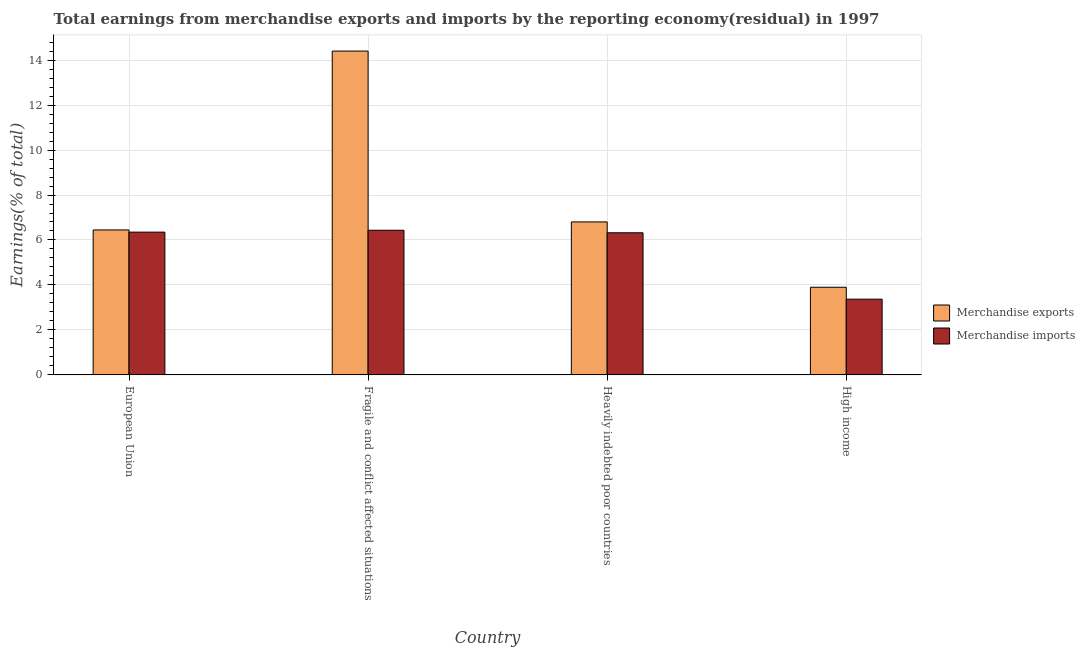How many different coloured bars are there?
Make the answer very short. 2. How many groups of bars are there?
Your response must be concise. 4. Are the number of bars per tick equal to the number of legend labels?
Your answer should be very brief. Yes. Are the number of bars on each tick of the X-axis equal?
Provide a succinct answer. Yes. What is the label of the 1st group of bars from the left?
Your answer should be compact. European Union. In how many cases, is the number of bars for a given country not equal to the number of legend labels?
Offer a terse response. 0. What is the earnings from merchandise imports in European Union?
Your response must be concise. 6.35. Across all countries, what is the maximum earnings from merchandise imports?
Your answer should be compact. 6.43. Across all countries, what is the minimum earnings from merchandise exports?
Ensure brevity in your answer.  3.9. In which country was the earnings from merchandise exports maximum?
Ensure brevity in your answer.  Fragile and conflict affected situations. What is the total earnings from merchandise imports in the graph?
Ensure brevity in your answer.  22.47. What is the difference between the earnings from merchandise imports in Fragile and conflict affected situations and that in Heavily indebted poor countries?
Your answer should be compact. 0.11. What is the difference between the earnings from merchandise exports in Heavily indebted poor countries and the earnings from merchandise imports in Fragile and conflict affected situations?
Ensure brevity in your answer.  0.37. What is the average earnings from merchandise imports per country?
Make the answer very short. 5.62. What is the difference between the earnings from merchandise imports and earnings from merchandise exports in European Union?
Give a very brief answer. -0.1. What is the ratio of the earnings from merchandise exports in Heavily indebted poor countries to that in High income?
Provide a short and direct response. 1.75. What is the difference between the highest and the second highest earnings from merchandise exports?
Offer a very short reply. 7.6. What is the difference between the highest and the lowest earnings from merchandise imports?
Make the answer very short. 3.06. In how many countries, is the earnings from merchandise exports greater than the average earnings from merchandise exports taken over all countries?
Keep it short and to the point. 1. What does the 2nd bar from the left in Heavily indebted poor countries represents?
Your answer should be compact. Merchandise imports. How many bars are there?
Offer a very short reply. 8. How many countries are there in the graph?
Make the answer very short. 4. Does the graph contain grids?
Offer a very short reply. Yes. Where does the legend appear in the graph?
Make the answer very short. Center right. How many legend labels are there?
Offer a very short reply. 2. What is the title of the graph?
Ensure brevity in your answer.  Total earnings from merchandise exports and imports by the reporting economy(residual) in 1997. What is the label or title of the X-axis?
Make the answer very short. Country. What is the label or title of the Y-axis?
Provide a short and direct response. Earnings(% of total). What is the Earnings(% of total) in Merchandise exports in European Union?
Provide a short and direct response. 6.45. What is the Earnings(% of total) of Merchandise imports in European Union?
Keep it short and to the point. 6.35. What is the Earnings(% of total) in Merchandise exports in Fragile and conflict affected situations?
Make the answer very short. 14.4. What is the Earnings(% of total) of Merchandise imports in Fragile and conflict affected situations?
Your response must be concise. 6.43. What is the Earnings(% of total) of Merchandise exports in Heavily indebted poor countries?
Your answer should be very brief. 6.8. What is the Earnings(% of total) in Merchandise imports in Heavily indebted poor countries?
Keep it short and to the point. 6.32. What is the Earnings(% of total) of Merchandise exports in High income?
Provide a succinct answer. 3.9. What is the Earnings(% of total) of Merchandise imports in High income?
Provide a short and direct response. 3.37. Across all countries, what is the maximum Earnings(% of total) in Merchandise exports?
Your answer should be compact. 14.4. Across all countries, what is the maximum Earnings(% of total) of Merchandise imports?
Make the answer very short. 6.43. Across all countries, what is the minimum Earnings(% of total) of Merchandise exports?
Keep it short and to the point. 3.9. Across all countries, what is the minimum Earnings(% of total) of Merchandise imports?
Give a very brief answer. 3.37. What is the total Earnings(% of total) of Merchandise exports in the graph?
Give a very brief answer. 31.55. What is the total Earnings(% of total) in Merchandise imports in the graph?
Provide a succinct answer. 22.47. What is the difference between the Earnings(% of total) of Merchandise exports in European Union and that in Fragile and conflict affected situations?
Provide a succinct answer. -7.95. What is the difference between the Earnings(% of total) in Merchandise imports in European Union and that in Fragile and conflict affected situations?
Make the answer very short. -0.08. What is the difference between the Earnings(% of total) in Merchandise exports in European Union and that in Heavily indebted poor countries?
Your answer should be very brief. -0.36. What is the difference between the Earnings(% of total) of Merchandise imports in European Union and that in Heavily indebted poor countries?
Offer a very short reply. 0.03. What is the difference between the Earnings(% of total) in Merchandise exports in European Union and that in High income?
Make the answer very short. 2.55. What is the difference between the Earnings(% of total) in Merchandise imports in European Union and that in High income?
Offer a terse response. 2.98. What is the difference between the Earnings(% of total) of Merchandise exports in Fragile and conflict affected situations and that in Heavily indebted poor countries?
Give a very brief answer. 7.6. What is the difference between the Earnings(% of total) in Merchandise imports in Fragile and conflict affected situations and that in Heavily indebted poor countries?
Ensure brevity in your answer.  0.11. What is the difference between the Earnings(% of total) of Merchandise exports in Fragile and conflict affected situations and that in High income?
Offer a very short reply. 10.5. What is the difference between the Earnings(% of total) of Merchandise imports in Fragile and conflict affected situations and that in High income?
Your answer should be compact. 3.06. What is the difference between the Earnings(% of total) in Merchandise exports in Heavily indebted poor countries and that in High income?
Ensure brevity in your answer.  2.91. What is the difference between the Earnings(% of total) in Merchandise imports in Heavily indebted poor countries and that in High income?
Make the answer very short. 2.95. What is the difference between the Earnings(% of total) in Merchandise exports in European Union and the Earnings(% of total) in Merchandise imports in Fragile and conflict affected situations?
Your answer should be very brief. 0.01. What is the difference between the Earnings(% of total) of Merchandise exports in European Union and the Earnings(% of total) of Merchandise imports in Heavily indebted poor countries?
Ensure brevity in your answer.  0.13. What is the difference between the Earnings(% of total) of Merchandise exports in European Union and the Earnings(% of total) of Merchandise imports in High income?
Your answer should be compact. 3.08. What is the difference between the Earnings(% of total) in Merchandise exports in Fragile and conflict affected situations and the Earnings(% of total) in Merchandise imports in Heavily indebted poor countries?
Provide a short and direct response. 8.08. What is the difference between the Earnings(% of total) in Merchandise exports in Fragile and conflict affected situations and the Earnings(% of total) in Merchandise imports in High income?
Provide a succinct answer. 11.03. What is the difference between the Earnings(% of total) in Merchandise exports in Heavily indebted poor countries and the Earnings(% of total) in Merchandise imports in High income?
Your response must be concise. 3.44. What is the average Earnings(% of total) of Merchandise exports per country?
Offer a very short reply. 7.89. What is the average Earnings(% of total) of Merchandise imports per country?
Your answer should be very brief. 5.62. What is the difference between the Earnings(% of total) of Merchandise exports and Earnings(% of total) of Merchandise imports in European Union?
Make the answer very short. 0.1. What is the difference between the Earnings(% of total) of Merchandise exports and Earnings(% of total) of Merchandise imports in Fragile and conflict affected situations?
Your answer should be compact. 7.97. What is the difference between the Earnings(% of total) in Merchandise exports and Earnings(% of total) in Merchandise imports in Heavily indebted poor countries?
Offer a terse response. 0.48. What is the difference between the Earnings(% of total) of Merchandise exports and Earnings(% of total) of Merchandise imports in High income?
Offer a very short reply. 0.53. What is the ratio of the Earnings(% of total) in Merchandise exports in European Union to that in Fragile and conflict affected situations?
Your response must be concise. 0.45. What is the ratio of the Earnings(% of total) in Merchandise imports in European Union to that in Fragile and conflict affected situations?
Make the answer very short. 0.99. What is the ratio of the Earnings(% of total) of Merchandise exports in European Union to that in Heavily indebted poor countries?
Give a very brief answer. 0.95. What is the ratio of the Earnings(% of total) in Merchandise exports in European Union to that in High income?
Offer a terse response. 1.65. What is the ratio of the Earnings(% of total) in Merchandise imports in European Union to that in High income?
Provide a succinct answer. 1.89. What is the ratio of the Earnings(% of total) of Merchandise exports in Fragile and conflict affected situations to that in Heavily indebted poor countries?
Make the answer very short. 2.12. What is the ratio of the Earnings(% of total) of Merchandise imports in Fragile and conflict affected situations to that in Heavily indebted poor countries?
Your answer should be compact. 1.02. What is the ratio of the Earnings(% of total) of Merchandise exports in Fragile and conflict affected situations to that in High income?
Your answer should be very brief. 3.69. What is the ratio of the Earnings(% of total) in Merchandise imports in Fragile and conflict affected situations to that in High income?
Provide a short and direct response. 1.91. What is the ratio of the Earnings(% of total) in Merchandise exports in Heavily indebted poor countries to that in High income?
Ensure brevity in your answer.  1.75. What is the ratio of the Earnings(% of total) in Merchandise imports in Heavily indebted poor countries to that in High income?
Offer a terse response. 1.88. What is the difference between the highest and the second highest Earnings(% of total) in Merchandise exports?
Ensure brevity in your answer.  7.6. What is the difference between the highest and the second highest Earnings(% of total) of Merchandise imports?
Provide a short and direct response. 0.08. What is the difference between the highest and the lowest Earnings(% of total) in Merchandise exports?
Offer a terse response. 10.5. What is the difference between the highest and the lowest Earnings(% of total) in Merchandise imports?
Ensure brevity in your answer.  3.06. 